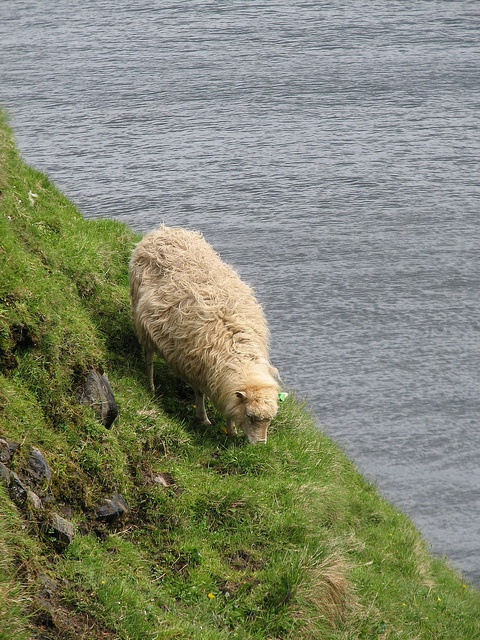Describe the objects in this image and their specific colors. I can see a sheep in darkgray, tan, and olive tones in this image. 